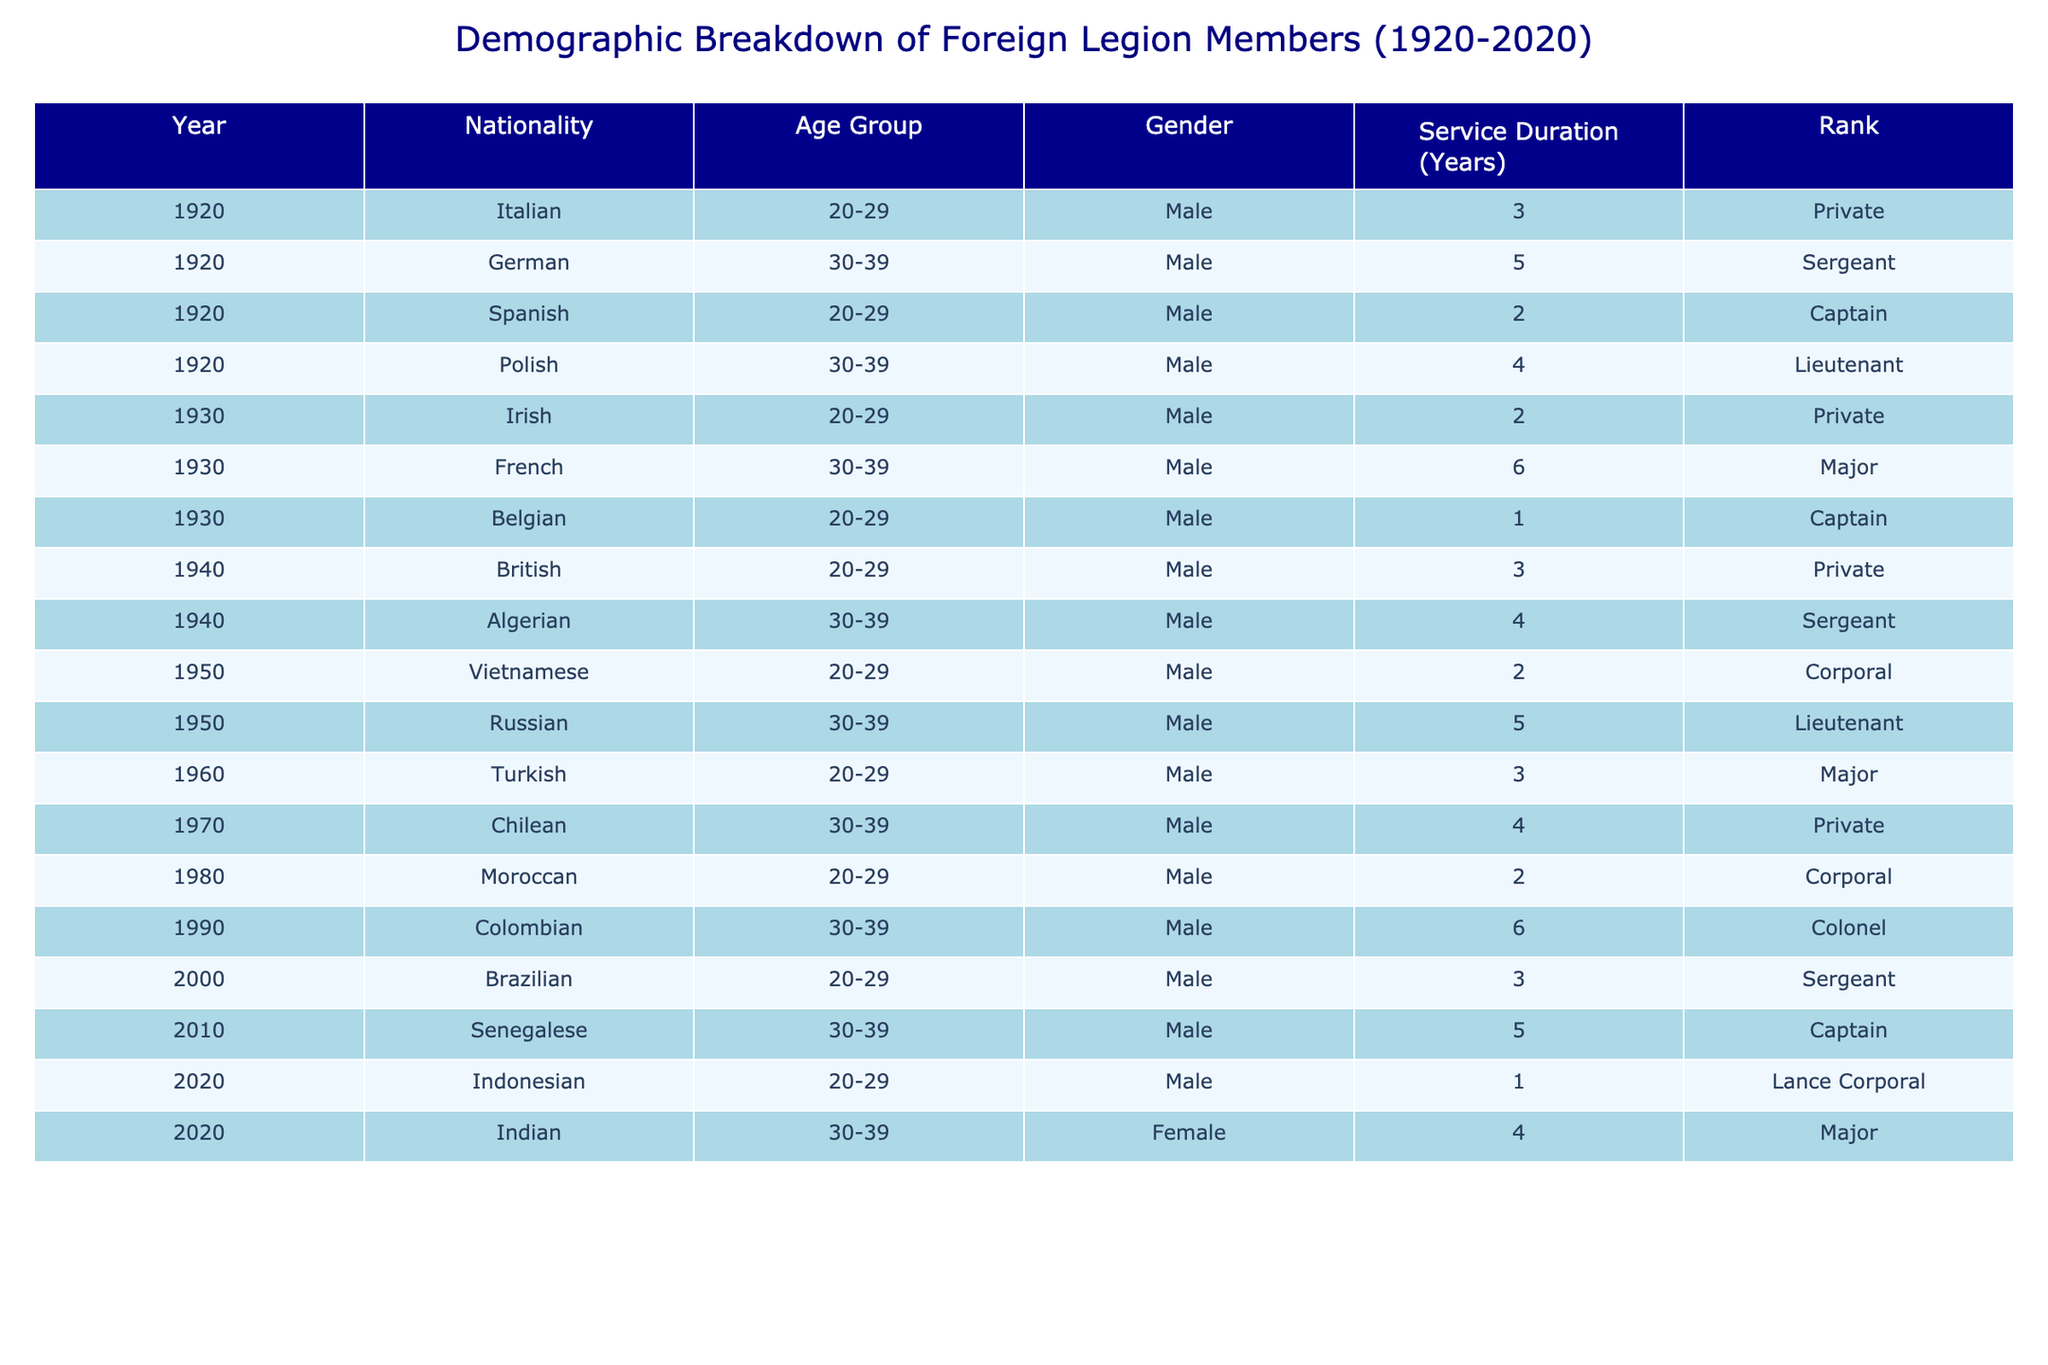What was the rank of the German member in 1920? According to the table, the member from Germany in 1920 held the rank of Sergeant. This can be found directly in the row corresponding to the year 1920 and the nationality German.
Answer: Sergeant How many years did the British member serve in 1940? The table indicates that the British member in 1940 served for 3 years. This is directly captured in the row corresponding to the year 1940 and nationality British.
Answer: 3 years Which age group had the highest representation in the dataset? To determine this, I check the age groups present in the table. The age groups are 20-29 and 30-39. Counting the entries for each age group, there are 7 entries for 20-29 and 6 entries for 30-39. Therefore, the 20-29 age group has the highest representation.
Answer: 20-29 What is the average service duration for members aged 30-39? To find the average service duration for members aged 30-39, I filter the table to include only those entries. The members aged 30-39 are from the years 1920, 1930, 1940, 1950, 1990, 2010, and the service durations are 5, 6, 4, 5, 6, and 4 years respectively. Summing these gives 30 years. There are 6 members; thus, the average is 30/6 = 5 years.
Answer: 5 years Is there a female member in the dataset? By examining the gender column, I find a member listed as female, specifically the Indian member in 2020. This confirms that there is indeed a female member represented in the data.
Answer: Yes How many members served more than 5 years? I can check the service durations in the table. The only members serving more than 5 years are the German (5), French (6), Russian (5), Colombian (6), and Senegalese (5) members from different years. Counting these entries, there are 3 members who served more than 5 years (French, Colombian).
Answer: 3 members Which nationality had the member with the highest rank in 1990? In 1990, the data shows that the Colombian member held a rank of Colonel, which is the highest rank represented in that year. This is determined by comparing the ranks of members listed for 1990.
Answer: Colombian How many total nationalities are represented in the dataset? Looking through the table, I note the different nationalities listed: Italian, German, Spanish, Polish, Irish, French, Belgian, British, Algerian, Vietnamese, Russian, Turkish, Chilean, Moroccan, Colombian, Brazilian, Senegalese, Indonesian, and Indian. Counting each unique nationality gives a total of 18.
Answer: 18 nationalities 